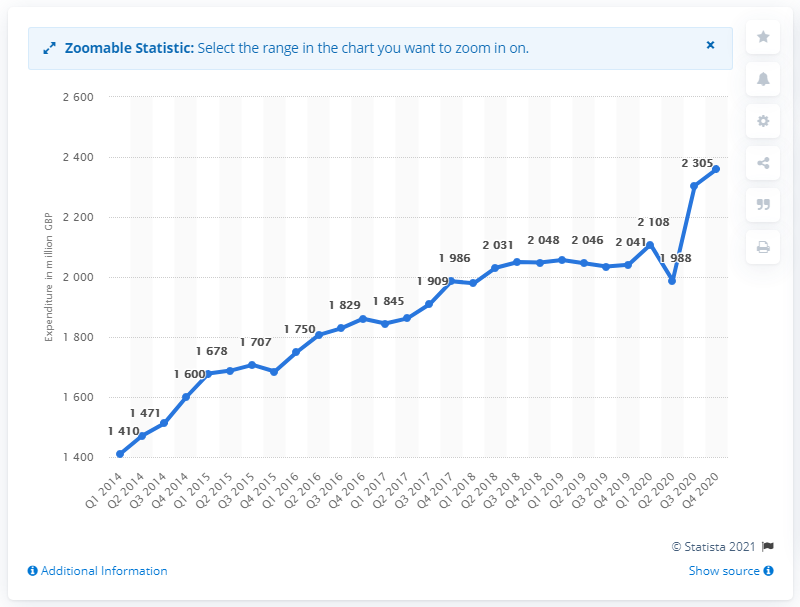Indicate a few pertinent items in this graphic. In the fourth quarter of 2020, the consumption of glassware, tableware, and household utensils was 2,360 units. Households purchased approximately 1410 units of glassware in the first quarter of 2014. 